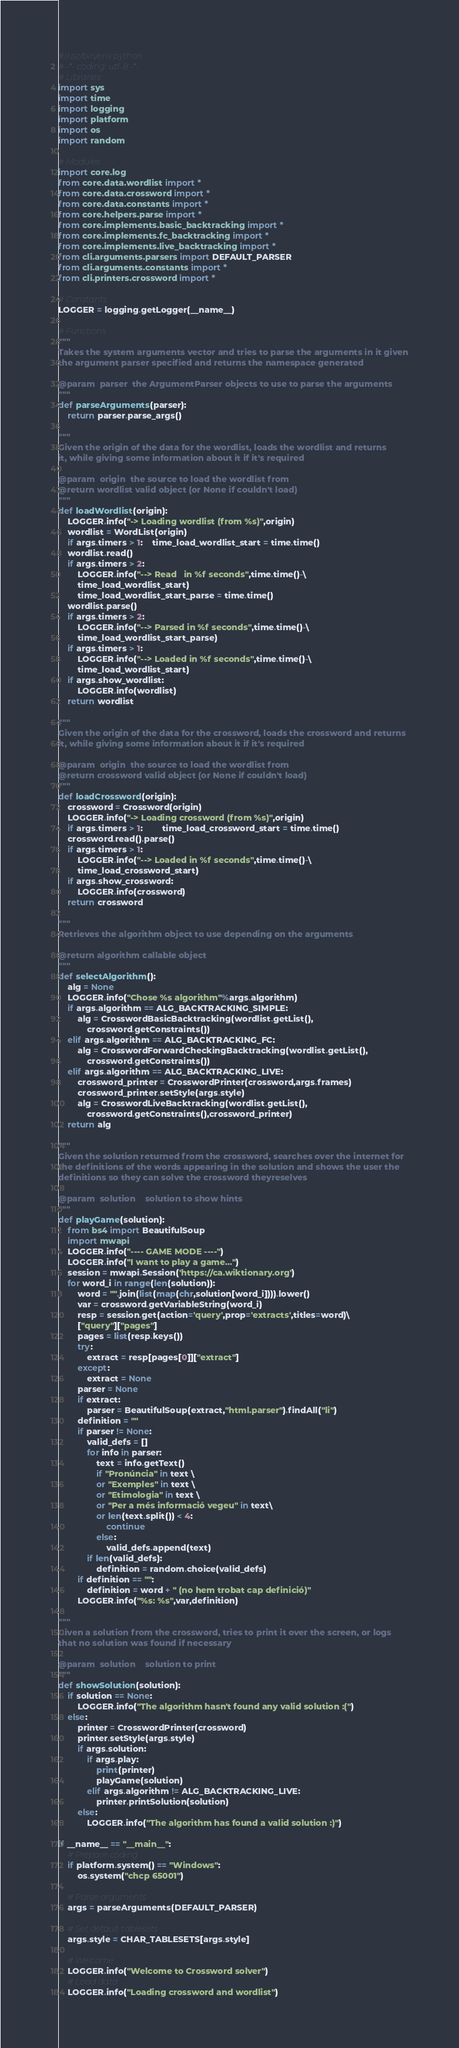Convert code to text. <code><loc_0><loc_0><loc_500><loc_500><_Python_>#!/usr/bin/env python
# -*- coding: utf-8 -*-
# Libraries
import sys
import time
import logging
import platform
import os
import random

# Modules
import core.log
from core.data.wordlist import *
from core.data.crossword import *
from core.data.constants import *
from core.helpers.parse import *
from core.implements.basic_backtracking import *
from core.implements.fc_backtracking import *
from core.implements.live_backtracking import *
from cli.arguments.parsers import DEFAULT_PARSER
from cli.arguments.constants import *
from cli.printers.crossword import *

# Constants
LOGGER = logging.getLogger(__name__)

# Functions
"""
Takes the system arguments vector and tries to parse the arguments in it given
the argument parser specified and returns the namespace generated

@param 	parser 	the ArgumentParser objects to use to parse the arguments
"""
def parseArguments(parser):
	return parser.parse_args()

"""
Given the origin of the data for the wordlist, loads the wordlist and returns
it, while giving some information about it if it's required

@param 	origin 	the source to load the wordlist from
@return wordlist valid object (or None if couldn't load)
"""
def loadWordlist(origin):
	LOGGER.info("-> Loading wordlist (from %s)",origin)
	wordlist = WordList(origin)
	if args.timers > 1: 	time_load_wordlist_start = time.time()
	wordlist.read()
	if args.timers > 2:
		LOGGER.info("--> Read   in %f seconds",time.time()-\
		time_load_wordlist_start)
		time_load_wordlist_start_parse = time.time()
	wordlist.parse()
	if args.timers > 2:
		LOGGER.info("--> Parsed in %f seconds",time.time()-\
		time_load_wordlist_start_parse)
	if args.timers > 1:
		LOGGER.info("--> Loaded in %f seconds",time.time()-\
		time_load_wordlist_start)
	if args.show_wordlist:
		LOGGER.info(wordlist)
	return wordlist

"""
Given the origin of the data for the crossword, loads the crossword and returns
it, while giving some information about it if it's required

@param 	origin 	the source to load the wordlist from
@return crossword valid object (or None if couldn't load)
"""
def loadCrossword(origin):
	crossword = Crossword(origin)
	LOGGER.info("-> Loading crossword (from %s)",origin)
	if args.timers > 1:		time_load_crossword_start = time.time()
	crossword.read().parse()
	if args.timers > 1:
		LOGGER.info("--> Loaded in %f seconds",time.time()-\
		time_load_crossword_start)
	if args.show_crossword:
		LOGGER.info(crossword)
	return crossword

"""
Retrieves the algorithm object to use depending on the arguments

@return algorithm callable object
"""
def selectAlgorithm():
	alg = None
	LOGGER.info("Chose %s algorithm"%args.algorithm)
	if args.algorithm == ALG_BACKTRACKING_SIMPLE:
		alg = CrosswordBasicBacktracking(wordlist.getList(),
			crossword.getConstraints())
	elif args.algorithm == ALG_BACKTRACKING_FC:
		alg = CrosswordForwardCheckingBacktracking(wordlist.getList(),
			crossword.getConstraints())
	elif args.algorithm == ALG_BACKTRACKING_LIVE:
		crossword_printer = CrosswordPrinter(crossword,args.frames)
		crossword_printer.setStyle(args.style)
		alg = CrosswordLiveBacktracking(wordlist.getList(),
			crossword.getConstraints(),crossword_printer)
	return alg

"""
Given the solution returned from the crossword, searches over the internet for
the definitions of the words appearing in the solution and shows the user the
definitions so they can solve the crossword theyreselves

@param 	solution 	solution to show hints
"""
def playGame(solution):
	from bs4 import BeautifulSoup
	import mwapi
	LOGGER.info("---- GAME MODE ----")
	LOGGER.info("I want to play a game...")
	session = mwapi.Session('https://ca.wiktionary.org')
	for word_i in range(len(solution)):
		word = "".join(list(map(chr,solution[word_i]))).lower()
		var = crossword.getVariableString(word_i)
		resp = session.get(action='query',prop='extracts',titles=word)\
		["query"]["pages"]
		pages = list(resp.keys())
		try:
			extract = resp[pages[0]]["extract"]
		except:
			extract = None
		parser = None
		if extract:
		 	parser = BeautifulSoup(extract,"html.parser").findAll("li")
		definition = ""
		if parser != None:
			valid_defs = []
			for info in parser:
				text = info.getText()
				if "Pronúncia" in text \
				or "Exemples" in text \
				or "Etimologia" in text \
				or "Per a més informació vegeu" in text\
				or len(text.split()) < 4:
					continue
				else:
					valid_defs.append(text)
			if len(valid_defs):
				definition = random.choice(valid_defs)
		if definition == "":
			definition = word + " (no hem trobat cap definició)"
		LOGGER.info("%s: %s",var,definition)

"""
Given a solution from the crossword, tries to print it over the screen, or logs
that no solution was found if necessary

@param 	solution 	solution to print
"""
def showSolution(solution):
	if solution == None:
		LOGGER.info("The algorithm hasn't found any valid solution :(")
	else:
		printer = CrosswordPrinter(crossword)
		printer.setStyle(args.style)
		if args.solution:
			if args.play:
				print(printer)
				playGame(solution)
			elif args.algorithm != ALG_BACKTRACKING_LIVE:
				printer.printSolution(solution)
		else:
			LOGGER.info("The algorithm has found a valid solution :)")

if __name__ == "__main__":
	# Prepare coding
	if platform.system() == "Windows":
		os.system("chcp 65001")

	# Parse arguments
	args = parseArguments(DEFAULT_PARSER)

	# Set default tablesets
	args.style = CHAR_TABLESETS[args.style]

	# Welcome
	LOGGER.info("Welcome to Crossword solver")
	# Load data
	LOGGER.info("Loading crossword and wordlist")</code> 